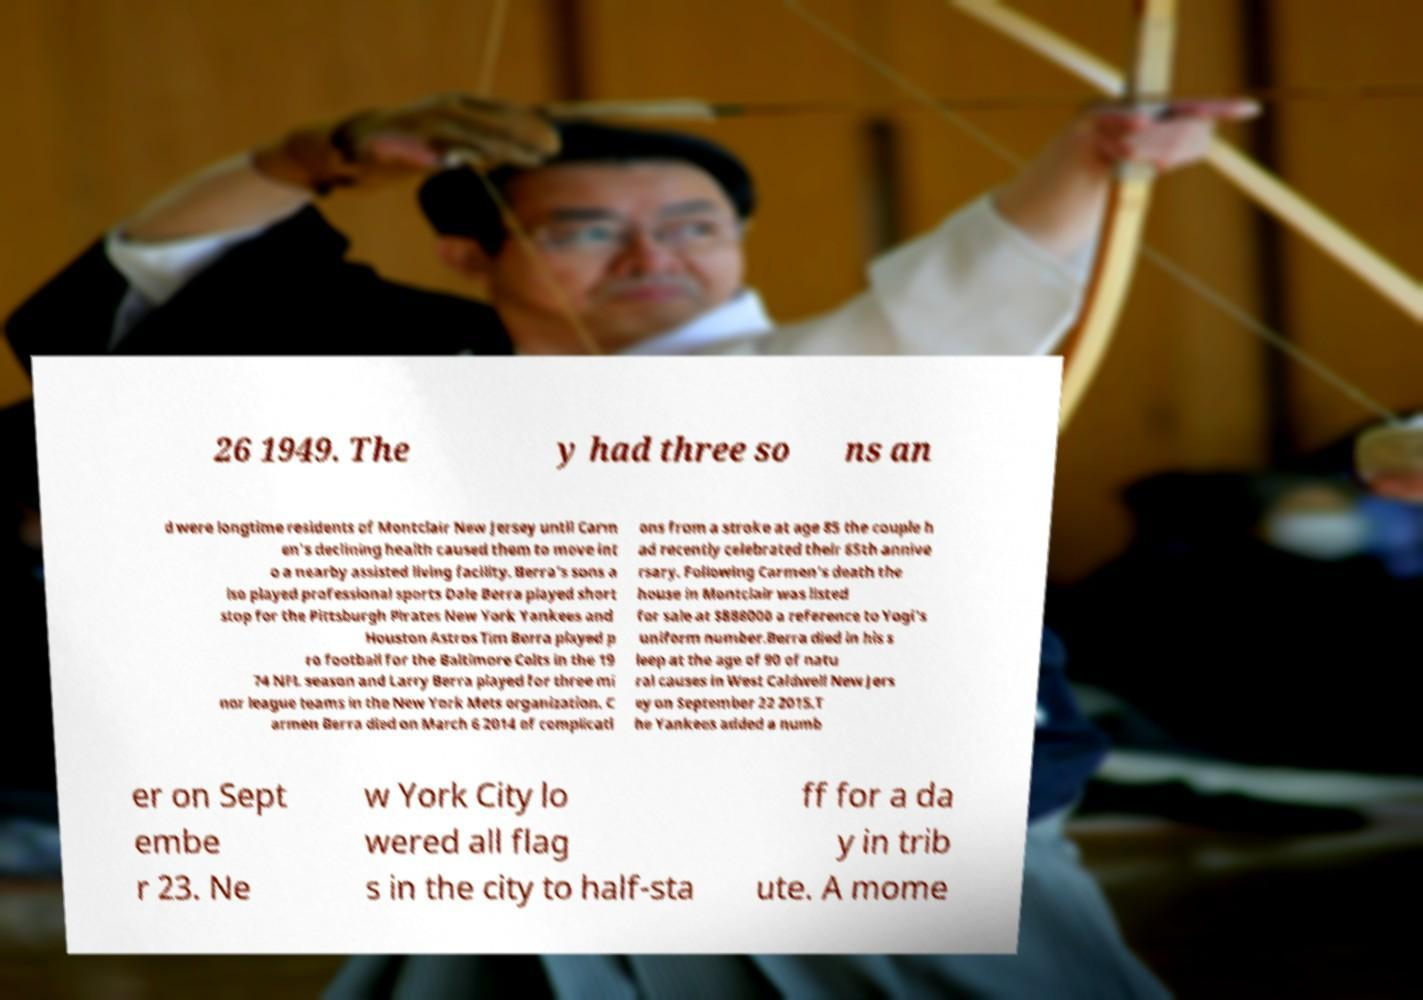What messages or text are displayed in this image? I need them in a readable, typed format. 26 1949. The y had three so ns an d were longtime residents of Montclair New Jersey until Carm en's declining health caused them to move int o a nearby assisted living facility. Berra's sons a lso played professional sports Dale Berra played short stop for the Pittsburgh Pirates New York Yankees and Houston Astros Tim Berra played p ro football for the Baltimore Colts in the 19 74 NFL season and Larry Berra played for three mi nor league teams in the New York Mets organization. C armen Berra died on March 6 2014 of complicati ons from a stroke at age 85 the couple h ad recently celebrated their 65th annive rsary. Following Carmen's death the house in Montclair was listed for sale at $888000 a reference to Yogi's uniform number.Berra died in his s leep at the age of 90 of natu ral causes in West Caldwell New Jers ey on September 22 2015.T he Yankees added a numb er on Sept embe r 23. Ne w York City lo wered all flag s in the city to half-sta ff for a da y in trib ute. A mome 